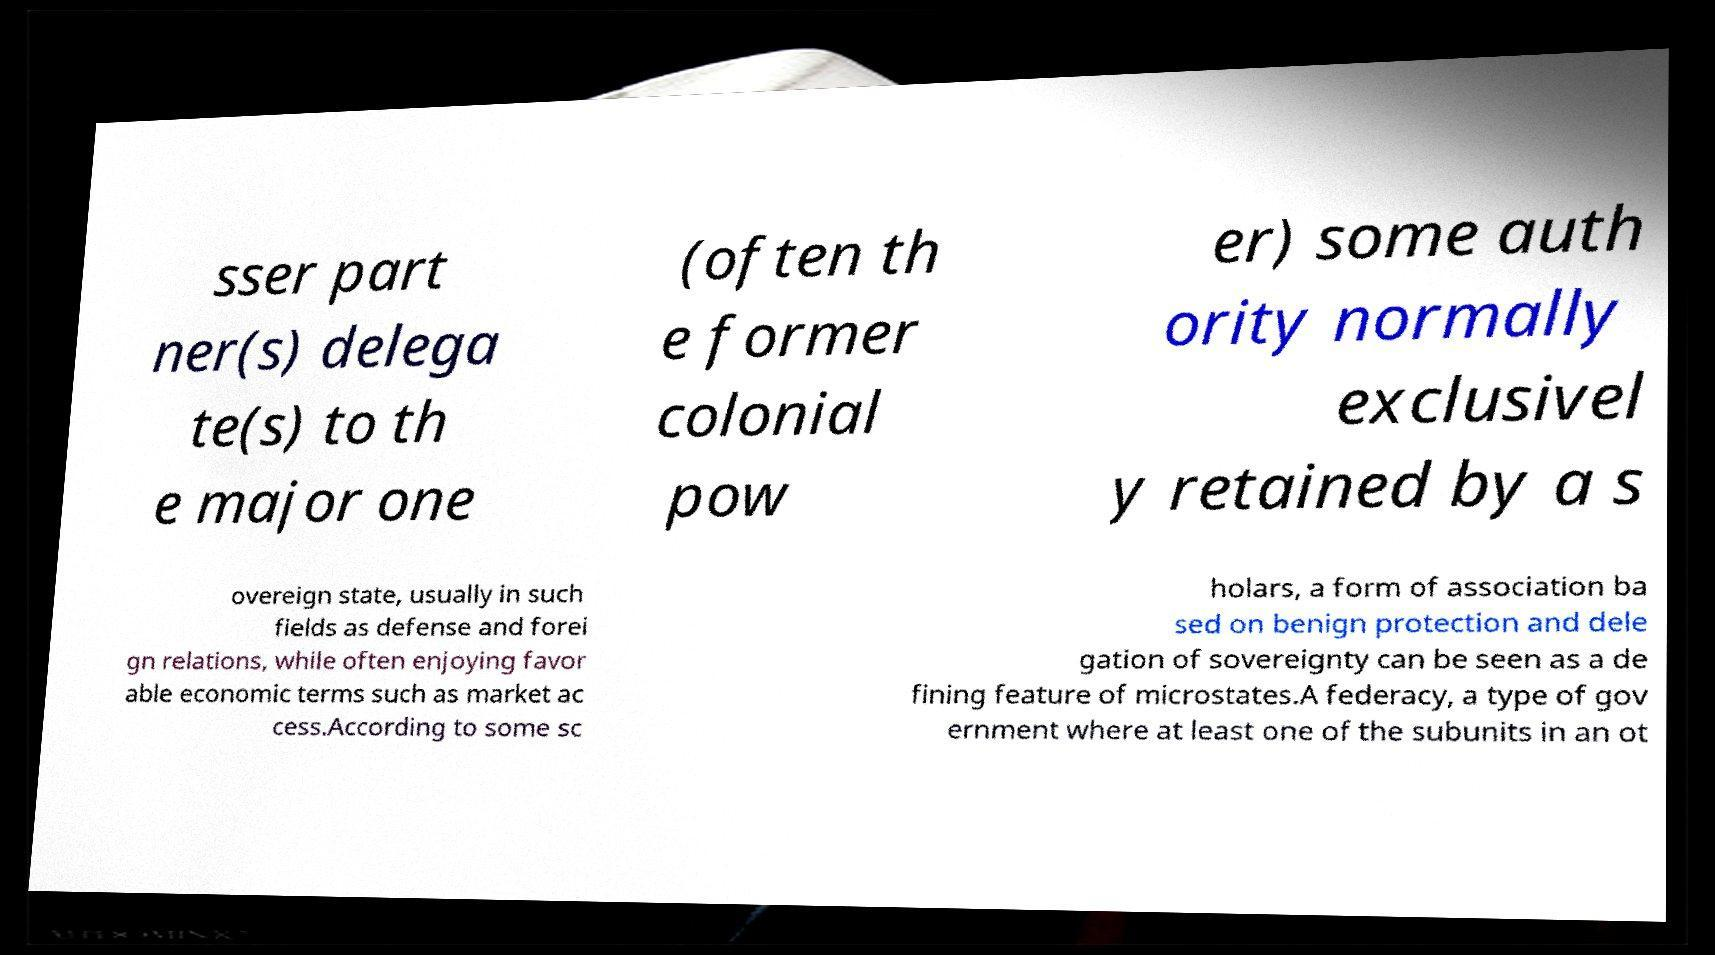For documentation purposes, I need the text within this image transcribed. Could you provide that? sser part ner(s) delega te(s) to th e major one (often th e former colonial pow er) some auth ority normally exclusivel y retained by a s overeign state, usually in such fields as defense and forei gn relations, while often enjoying favor able economic terms such as market ac cess.According to some sc holars, a form of association ba sed on benign protection and dele gation of sovereignty can be seen as a de fining feature of microstates.A federacy, a type of gov ernment where at least one of the subunits in an ot 